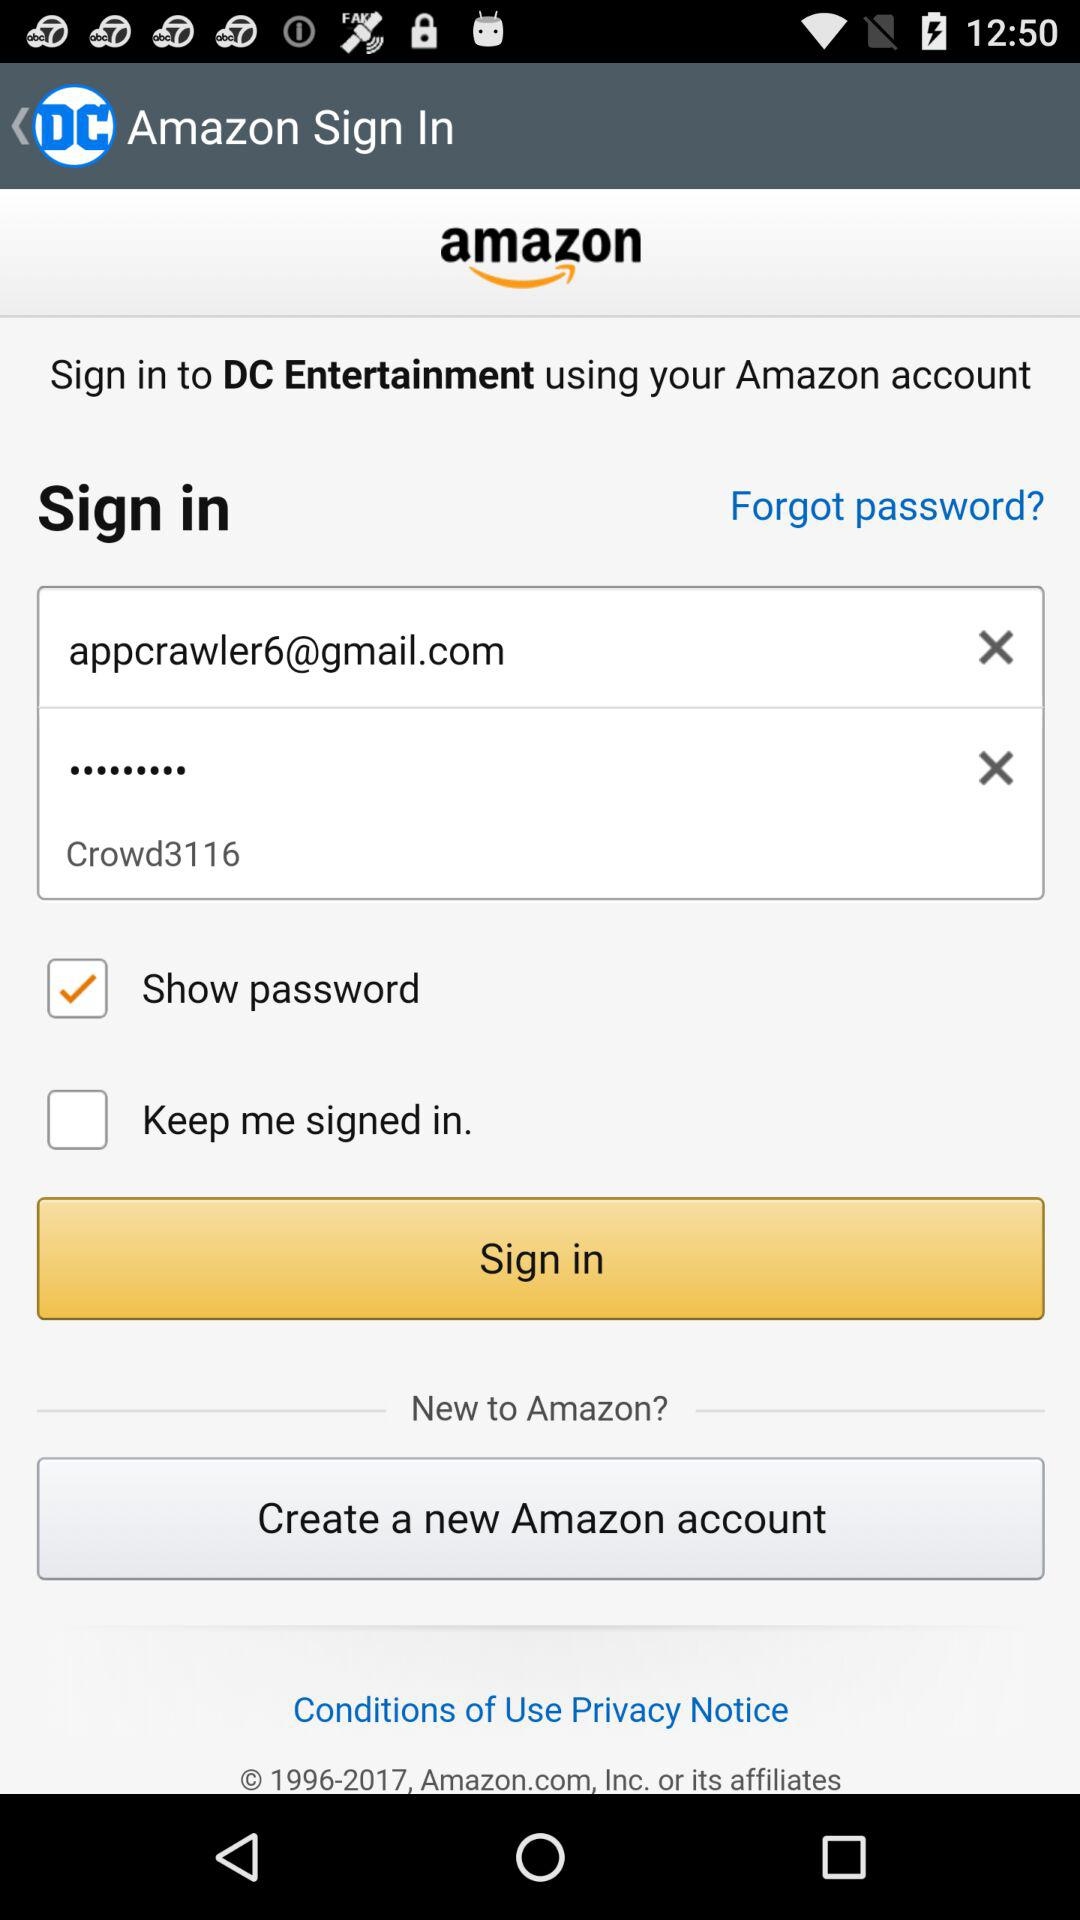What is the status of "Show password"? The status is "on". 